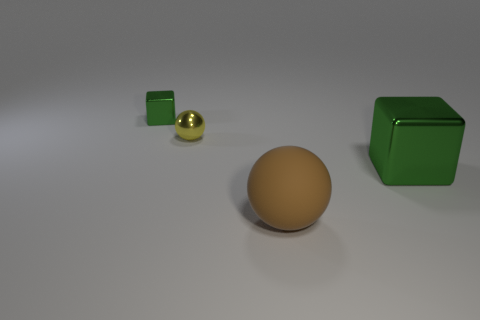What is the size of the other shiny block that is the same color as the large metallic cube?
Your response must be concise. Small. There is a thing that is the same color as the small block; what is its material?
Your answer should be compact. Metal. Is there a large shiny cube that has the same color as the small block?
Make the answer very short. Yes. There is a big metal thing; what shape is it?
Provide a short and direct response. Cube. What is the material of the other thing that is the same shape as the yellow thing?
Keep it short and to the point. Rubber. Are there more gray shiny things than brown rubber things?
Ensure brevity in your answer.  No. What number of other objects are the same color as the big matte object?
Ensure brevity in your answer.  0. Is the large green cube made of the same material as the small object right of the tiny green shiny block?
Offer a terse response. Yes. There is a ball behind the green metal block on the right side of the large brown rubber thing; how many small yellow spheres are on the right side of it?
Give a very brief answer. 0. Are there fewer rubber balls left of the tiny yellow metallic object than green shiny cubes to the left of the brown matte object?
Offer a very short reply. Yes. 